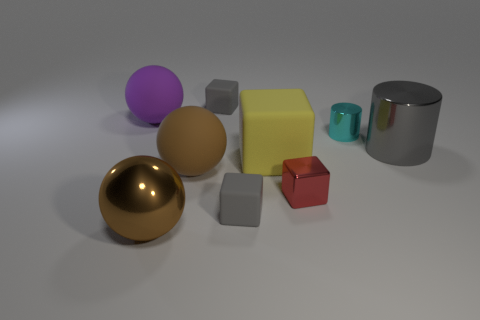There is a gray metal cylinder; what number of red metallic things are right of it?
Give a very brief answer. 0. Does the big cylinder have the same color as the tiny cylinder?
Keep it short and to the point. No. There is a big brown object that is made of the same material as the tiny cyan cylinder; what shape is it?
Your response must be concise. Sphere. There is a gray rubber object in front of the large purple ball; is it the same shape as the yellow object?
Make the answer very short. Yes. How many yellow things are either matte objects or small blocks?
Give a very brief answer. 1. Are there an equal number of tiny metal blocks that are in front of the big purple object and matte spheres right of the small red shiny thing?
Provide a succinct answer. No. There is a small block to the left of the tiny gray rubber thing in front of the tiny gray block behind the small cyan cylinder; what is its color?
Keep it short and to the point. Gray. Are there any other things that are the same color as the big metal cylinder?
Your response must be concise. Yes. There is a large matte thing that is the same color as the big metallic sphere; what is its shape?
Give a very brief answer. Sphere. There is a ball that is in front of the small red metal object; what size is it?
Give a very brief answer. Large. 